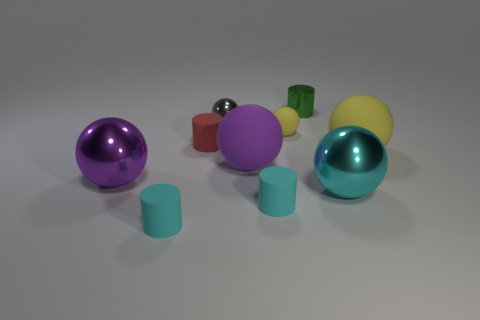Is the number of yellow rubber spheres in front of the big yellow rubber object greater than the number of large purple shiny spheres?
Your answer should be very brief. No. There is a metallic thing that is both behind the purple metal thing and on the right side of the tiny yellow rubber sphere; what is its size?
Offer a terse response. Small. There is a cyan object that is the same shape as the small gray thing; what is it made of?
Keep it short and to the point. Metal. Do the cyan rubber cylinder left of the purple matte ball and the red cylinder have the same size?
Provide a succinct answer. Yes. There is a object that is both behind the small red object and on the right side of the small matte ball; what color is it?
Your answer should be compact. Green. There is a cylinder that is behind the gray object; what number of small green cylinders are in front of it?
Ensure brevity in your answer.  0. Do the big purple shiny object and the gray object have the same shape?
Offer a very short reply. Yes. Is there anything else that has the same color as the tiny shiny ball?
Keep it short and to the point. No. There is a red object; is its shape the same as the cyan metal thing in front of the gray metal object?
Offer a very short reply. No. What is the color of the big matte thing right of the metal ball that is right of the yellow sphere on the left side of the large yellow sphere?
Make the answer very short. Yellow. 